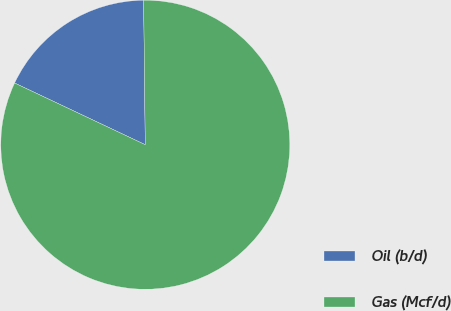<chart> <loc_0><loc_0><loc_500><loc_500><pie_chart><fcel>Oil (b/d)<fcel>Gas (Mcf/d)<nl><fcel>17.8%<fcel>82.2%<nl></chart> 